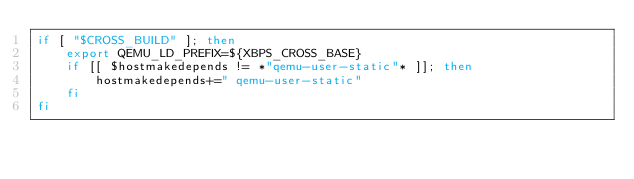Convert code to text. <code><loc_0><loc_0><loc_500><loc_500><_Bash_>if [ "$CROSS_BUILD" ]; then
	export QEMU_LD_PREFIX=${XBPS_CROSS_BASE}
	if [[ $hostmakedepends != *"qemu-user-static"* ]]; then
		hostmakedepends+=" qemu-user-static"
	fi
fi
</code> 